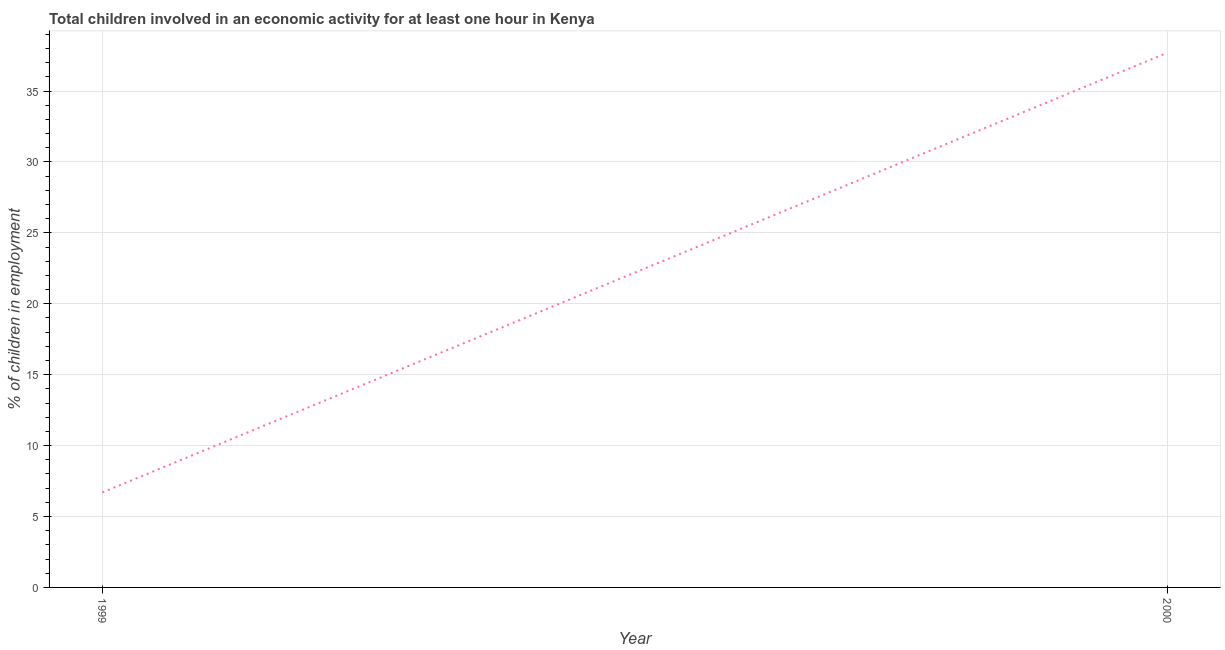Across all years, what is the maximum percentage of children in employment?
Provide a short and direct response. 37.7. Across all years, what is the minimum percentage of children in employment?
Provide a succinct answer. 6.7. What is the sum of the percentage of children in employment?
Provide a succinct answer. 44.4. What is the difference between the percentage of children in employment in 1999 and 2000?
Provide a succinct answer. -31. What is the average percentage of children in employment per year?
Your response must be concise. 22.2. What is the median percentage of children in employment?
Keep it short and to the point. 22.2. Do a majority of the years between 1999 and 2000 (inclusive) have percentage of children in employment greater than 31 %?
Give a very brief answer. No. What is the ratio of the percentage of children in employment in 1999 to that in 2000?
Your answer should be very brief. 0.18. In how many years, is the percentage of children in employment greater than the average percentage of children in employment taken over all years?
Your answer should be compact. 1. How many lines are there?
Give a very brief answer. 1. What is the difference between two consecutive major ticks on the Y-axis?
Your answer should be very brief. 5. Are the values on the major ticks of Y-axis written in scientific E-notation?
Offer a very short reply. No. Does the graph contain any zero values?
Ensure brevity in your answer.  No. Does the graph contain grids?
Offer a very short reply. Yes. What is the title of the graph?
Your answer should be compact. Total children involved in an economic activity for at least one hour in Kenya. What is the label or title of the Y-axis?
Keep it short and to the point. % of children in employment. What is the % of children in employment in 1999?
Make the answer very short. 6.7. What is the % of children in employment of 2000?
Your response must be concise. 37.7. What is the difference between the % of children in employment in 1999 and 2000?
Ensure brevity in your answer.  -31. What is the ratio of the % of children in employment in 1999 to that in 2000?
Provide a succinct answer. 0.18. 